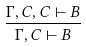Convert formula to latex. <formula><loc_0><loc_0><loc_500><loc_500>\frac { \Gamma , C , C \vdash B } { \Gamma , C \vdash B }</formula> 